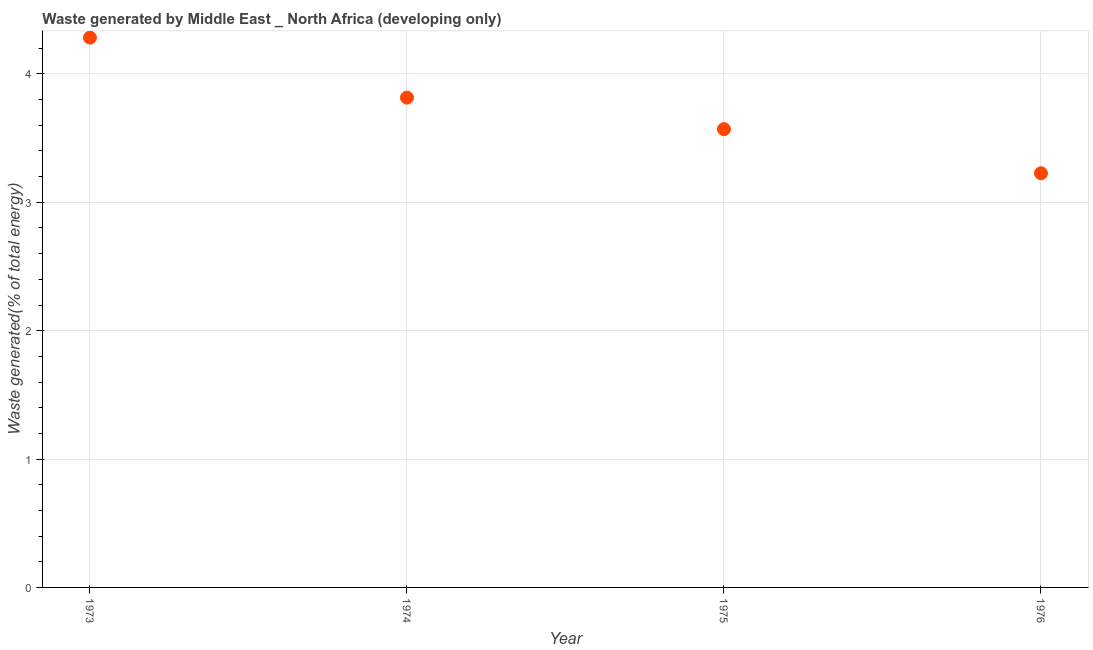What is the amount of waste generated in 1976?
Ensure brevity in your answer.  3.23. Across all years, what is the maximum amount of waste generated?
Provide a succinct answer. 4.28. Across all years, what is the minimum amount of waste generated?
Give a very brief answer. 3.23. In which year was the amount of waste generated maximum?
Provide a short and direct response. 1973. In which year was the amount of waste generated minimum?
Your answer should be compact. 1976. What is the sum of the amount of waste generated?
Ensure brevity in your answer.  14.9. What is the difference between the amount of waste generated in 1973 and 1975?
Your answer should be very brief. 0.71. What is the average amount of waste generated per year?
Make the answer very short. 3.72. What is the median amount of waste generated?
Ensure brevity in your answer.  3.69. What is the ratio of the amount of waste generated in 1973 to that in 1976?
Keep it short and to the point. 1.33. What is the difference between the highest and the second highest amount of waste generated?
Offer a terse response. 0.47. Is the sum of the amount of waste generated in 1974 and 1975 greater than the maximum amount of waste generated across all years?
Provide a succinct answer. Yes. What is the difference between the highest and the lowest amount of waste generated?
Offer a terse response. 1.06. How many dotlines are there?
Ensure brevity in your answer.  1. Are the values on the major ticks of Y-axis written in scientific E-notation?
Offer a very short reply. No. Does the graph contain any zero values?
Offer a very short reply. No. Does the graph contain grids?
Keep it short and to the point. Yes. What is the title of the graph?
Your answer should be compact. Waste generated by Middle East _ North Africa (developing only). What is the label or title of the Y-axis?
Provide a succinct answer. Waste generated(% of total energy). What is the Waste generated(% of total energy) in 1973?
Your answer should be very brief. 4.28. What is the Waste generated(% of total energy) in 1974?
Your response must be concise. 3.82. What is the Waste generated(% of total energy) in 1975?
Offer a terse response. 3.57. What is the Waste generated(% of total energy) in 1976?
Ensure brevity in your answer.  3.23. What is the difference between the Waste generated(% of total energy) in 1973 and 1974?
Provide a short and direct response. 0.47. What is the difference between the Waste generated(% of total energy) in 1973 and 1975?
Give a very brief answer. 0.71. What is the difference between the Waste generated(% of total energy) in 1973 and 1976?
Keep it short and to the point. 1.06. What is the difference between the Waste generated(% of total energy) in 1974 and 1975?
Keep it short and to the point. 0.25. What is the difference between the Waste generated(% of total energy) in 1974 and 1976?
Your answer should be very brief. 0.59. What is the difference between the Waste generated(% of total energy) in 1975 and 1976?
Offer a very short reply. 0.34. What is the ratio of the Waste generated(% of total energy) in 1973 to that in 1974?
Your answer should be compact. 1.12. What is the ratio of the Waste generated(% of total energy) in 1973 to that in 1975?
Your answer should be very brief. 1.2. What is the ratio of the Waste generated(% of total energy) in 1973 to that in 1976?
Give a very brief answer. 1.33. What is the ratio of the Waste generated(% of total energy) in 1974 to that in 1975?
Ensure brevity in your answer.  1.07. What is the ratio of the Waste generated(% of total energy) in 1974 to that in 1976?
Offer a terse response. 1.18. What is the ratio of the Waste generated(% of total energy) in 1975 to that in 1976?
Make the answer very short. 1.11. 